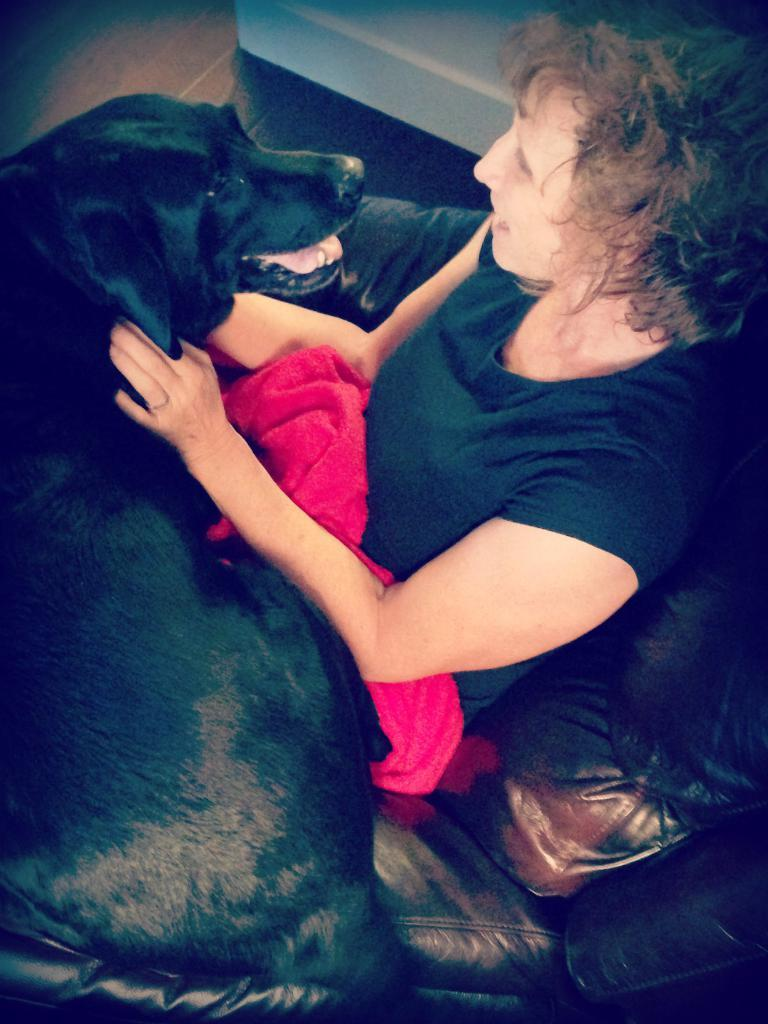Who is the main subject in the image? There is a lady in the image. What is the lady doing in the image? The lady is sitting on a sofa and holding a black dog. What is the lady's interaction with the dog? The lady is looking at the dog's face. What type of steel is used to build the houses in the image? There are no houses present in the image, and therefore no steel can be observed. What kind of locket is the lady wearing in the image? There is no locket visible on the lady in the image. 